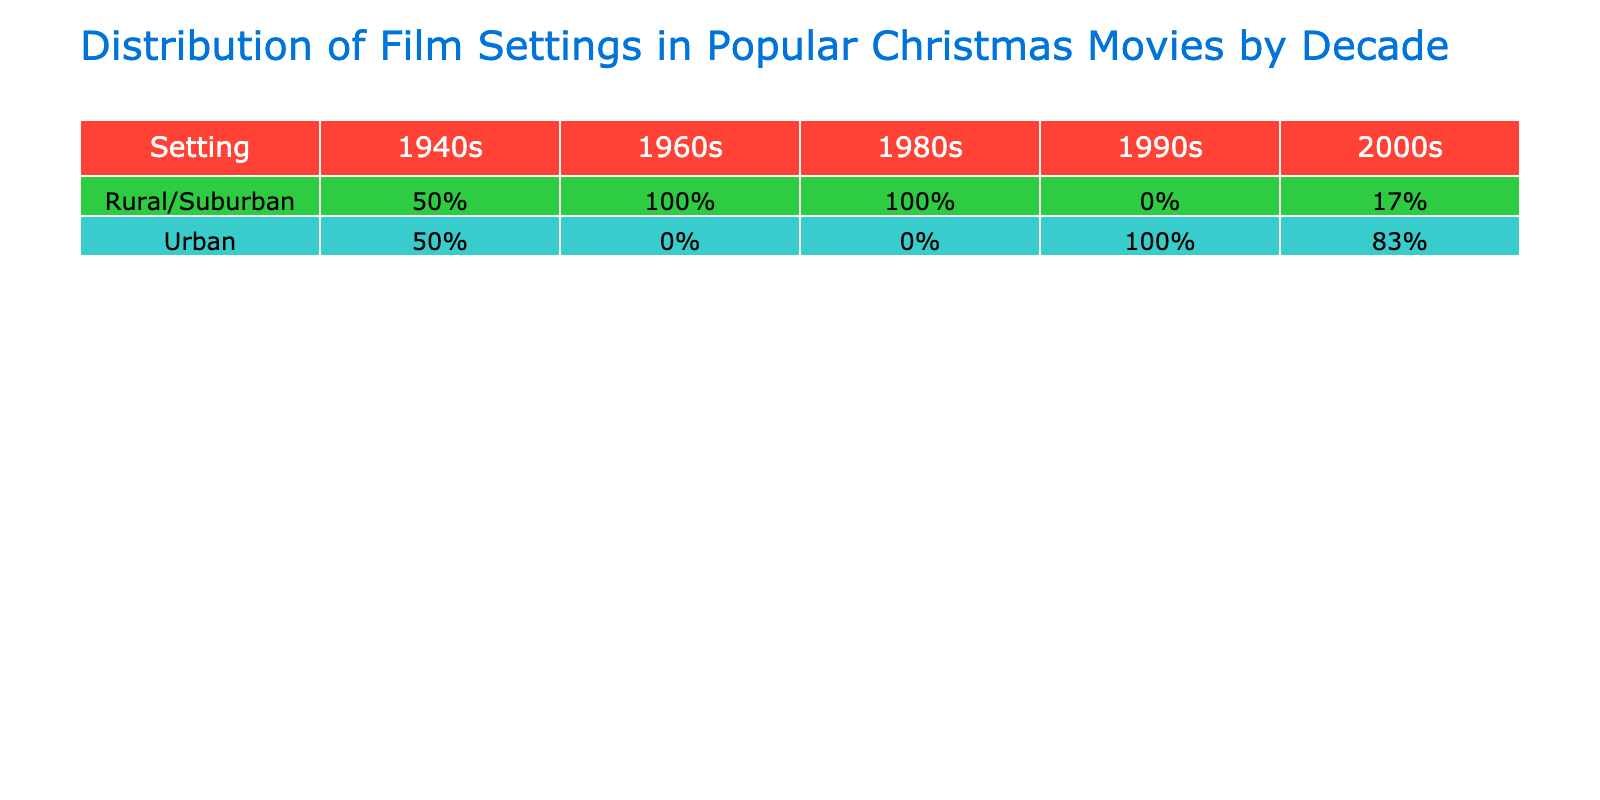What percentage of films from the 2000s are set in urban locations? In the 2000s, there are 6 films (The Polar Express, Elf, How the Grinch Stole Christmas, Love Actually, The Holiday, and The Family Stone). Out of these, 5 films are set in urban locations. Therefore, the percentage of urban films in the 2000s is (5/6)*100 = 83.33%.
Answer: 83.33% How many films from the 1990s are set in rural or suburban areas? In the 1990s, we have three movies (Home Alone, Christmas Vacation, and Jingle All the Way). Among these, Christmas Vacation and Home Alone can be classified as suburban, while none are rural. Thus, there are 2 films that fit the criteria.
Answer: 2 Is "It's a Wonderful Life" set in a rural area? "It's a Wonderful Life" features a setting identified as a small town (Bedford Falls), which qualifies as rural.
Answer: Yes Which decade has the highest percentage of films set in urban areas? By evaluating each decade's total number of films and counting how many are urban, we find that the 2000s has the highest percentage. The films are dominated by urban settings (80% or more) in that decade compared to the others.
Answer: 2000s What is the percentage of films set in rural/suburban areas across all decades? Calculating the total number of films that are rural or suburban (It's a Wonderful Life, Frosty the Snowman, A Charlie Brown Christmas, and Christmas Vacation) gives us 4 films out of a total of 13. Therefore, the percentage is (4/13)*100 = 30.77%.
Answer: 30.77% Are more films set in urban locations compared to rural locations in the 1980s? Analyzing the 1980s, there are 3 films: Home Alone (urban), Christmas Vacation (suburban), and Jingle All the Way (urban). This results in 2 urban films and 1 suburban/ none rural, thus confirming that urban films outnumber rural ones.
Answer: Yes 